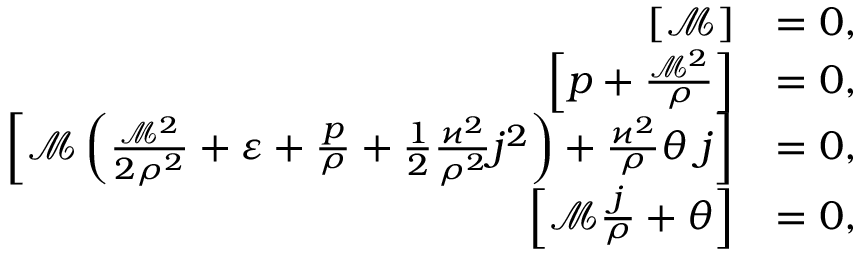Convert formula to latex. <formula><loc_0><loc_0><loc_500><loc_500>\begin{array} { r l } { \left [ \mathcal { M } \right ] } & { = 0 , } \\ { \left [ p + \frac { \mathcal { M } ^ { 2 } } { \rho } \right ] } & { = 0 , } \\ { \left [ \mathcal { M } \left ( \frac { \mathcal { M } ^ { 2 } } { 2 \rho ^ { 2 } } + \varepsilon + \frac { p } { \rho } + \frac { 1 } { 2 } \frac { \varkappa ^ { 2 } } { \rho ^ { 2 } } j ^ { 2 } \right ) + \frac { \varkappa ^ { 2 } } { \rho } \theta \, j \right ] } & { = 0 , } \\ { \left [ \mathcal { M } \frac { j } { \rho } + \theta \right ] } & { = 0 , } \end{array}</formula> 